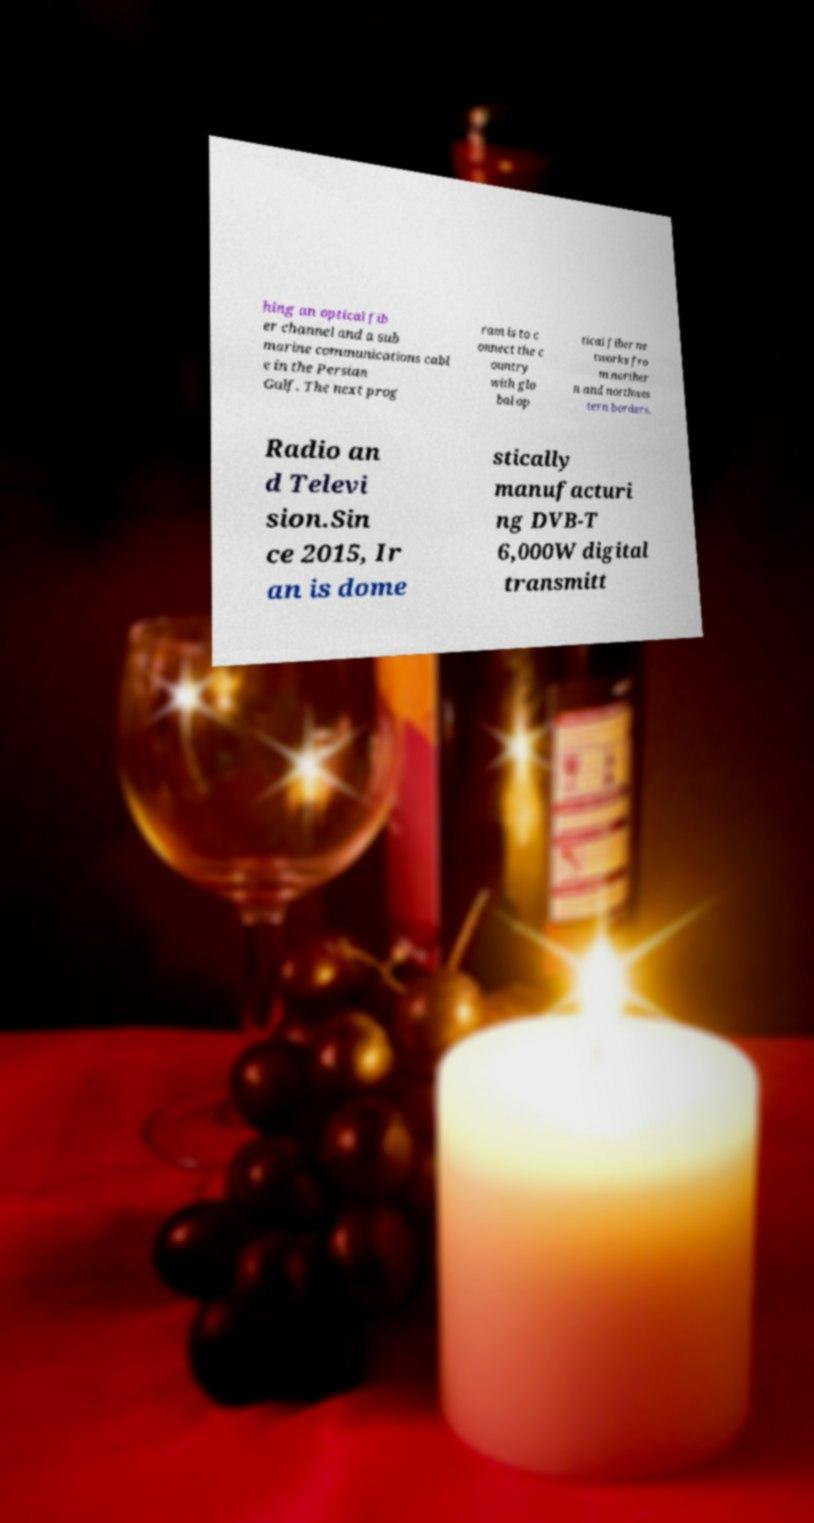Could you extract and type out the text from this image? hing an optical fib er channel and a sub marine communications cabl e in the Persian Gulf. The next prog ram is to c onnect the c ountry with glo bal op tical fiber ne tworks fro m norther n and northwes tern borders. Radio an d Televi sion.Sin ce 2015, Ir an is dome stically manufacturi ng DVB-T 6,000W digital transmitt 